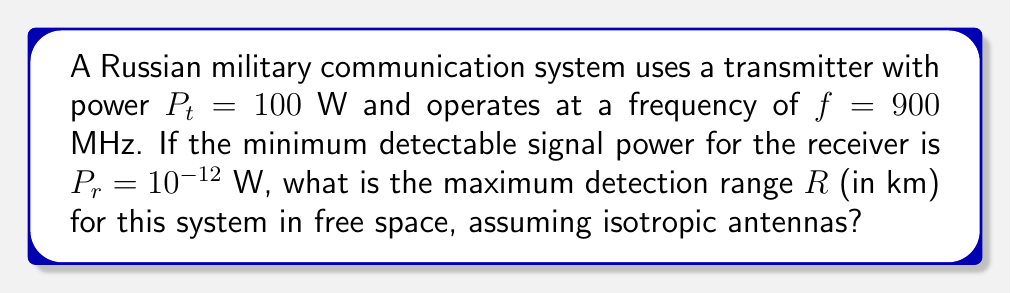What is the answer to this math problem? To solve this problem, we'll use the Friis transmission equation, which relates the transmitted power to the received power in free space:

$$\frac{P_r}{P_t} = G_t G_r \left(\frac{\lambda}{4\pi R}\right)^2$$

Where:
$P_r$ = Received power
$P_t$ = Transmitted power
$G_t$ = Transmitter antenna gain (1 for isotropic)
$G_r$ = Receiver antenna gain (1 for isotropic)
$\lambda$ = Wavelength
$R$ = Distance between transmitter and receiver

Step 1: Calculate the wavelength $\lambda$
$$\lambda = \frac{c}{f} = \frac{3 \times 10^8 \text{ m/s}}{900 \times 10^6 \text{ Hz}} = 0.3333 \text{ m}$$

Step 2: Rearrange the Friis equation to solve for R
$$R = \frac{\lambda}{4\pi} \sqrt{\frac{P_t}{P_r}}$$

Step 3: Substitute the known values
$$R = \frac{0.3333}{4\pi} \sqrt{\frac{100}{10^{-12}}}$$

Step 4: Calculate R
$$R = 0.02653 \sqrt{10^{14}} = 265,258.26 \text{ m} = 265.26 \text{ km}$$
Answer: 265.26 km 